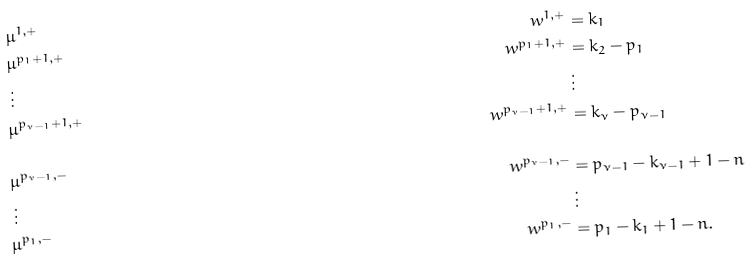<formula> <loc_0><loc_0><loc_500><loc_500>& \mu ^ { 1 , + } & w ^ { 1 , + } & = k _ { 1 } \\ & \mu ^ { p _ { 1 } + 1 , + } & w ^ { p _ { 1 } + 1 , + } & = k _ { 2 } - p _ { 1 } \\ & \, \vdots & & \, \vdots \\ & \mu ^ { p _ { \nu - 1 } + 1 , + } & w ^ { p _ { \nu - 1 } + 1 , + } & = k _ { \nu } - p _ { \nu - 1 } \\ & & & \\ & \mu ^ { p _ { \nu - 1 } , - } & w ^ { p _ { \nu - 1 } , - } & = p _ { \nu - 1 } - k _ { \nu - 1 } + 1 - n \\ & \, \vdots & & \, \vdots \\ & \mu ^ { p _ { 1 } , - } & w ^ { p _ { 1 } , - } & = p _ { 1 } - k _ { 1 } + 1 - n .</formula> 